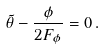Convert formula to latex. <formula><loc_0><loc_0><loc_500><loc_500>\tilde { \theta } - \frac { \phi } { 2 F _ { \phi } } = 0 \, .</formula> 